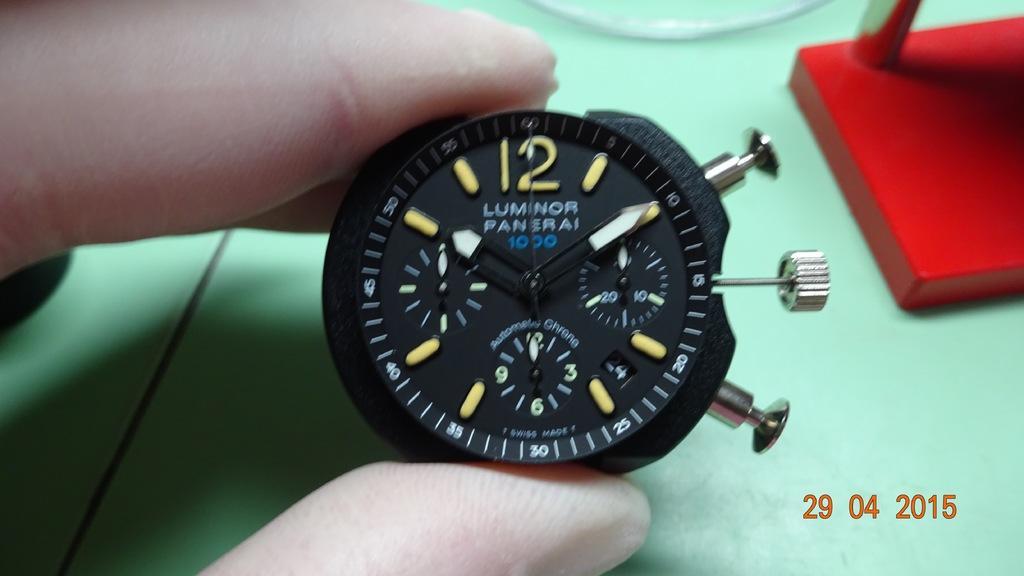Please provide a concise description of this image. In this image I can see in the middle there is an analog watch in black color, a human is holding it. In the right hand side bottom there are numbers. 